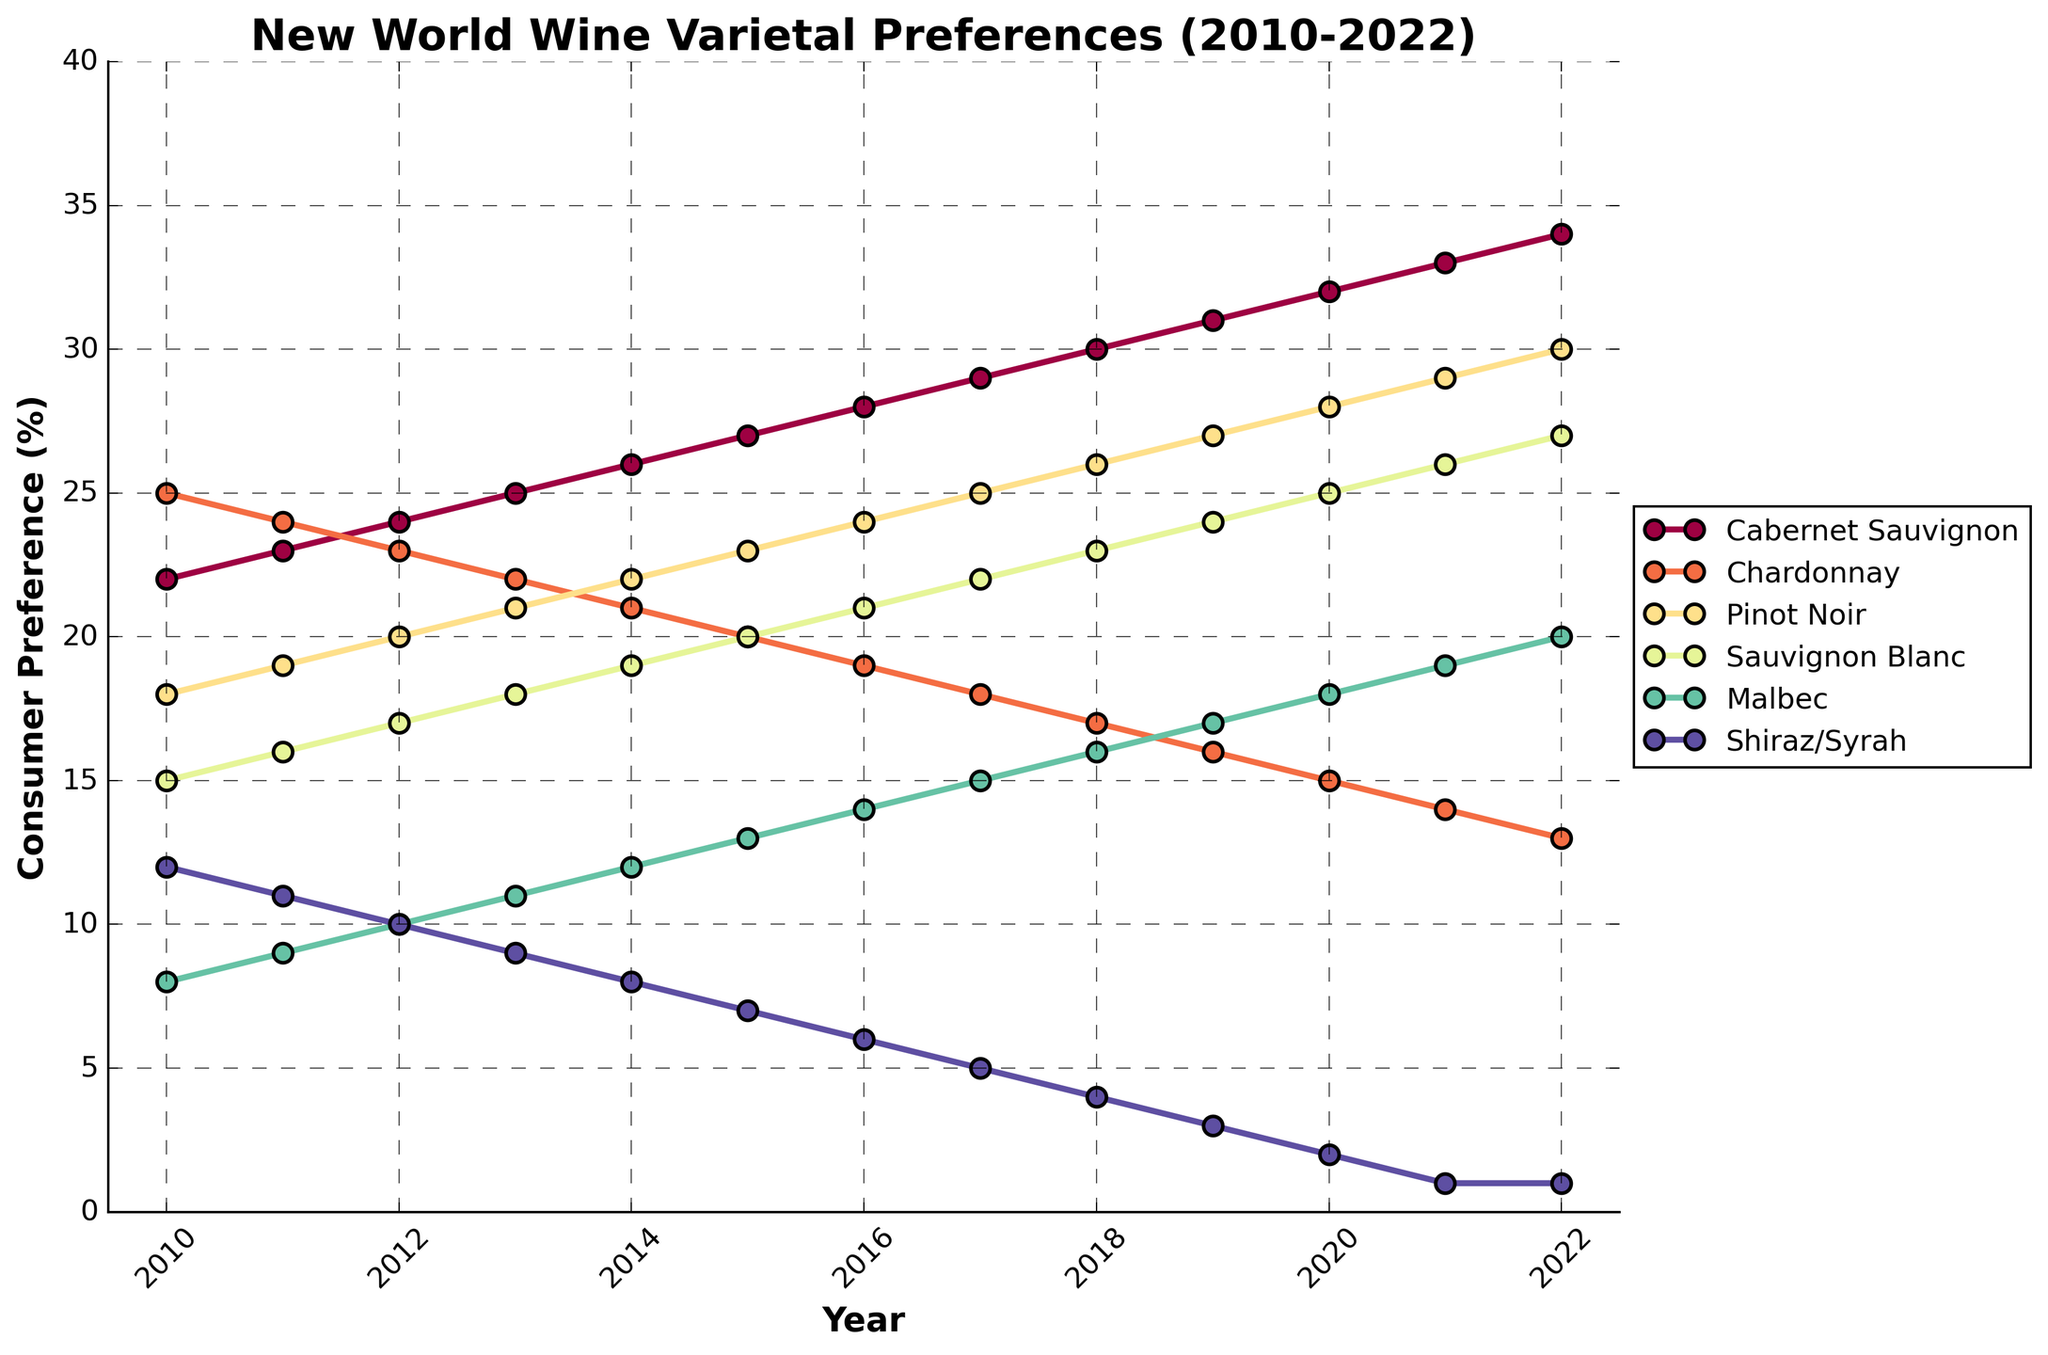Which varietal shows the most dramatic increase in consumer preference from 2010 to 2022? To find the varietal with the most dramatic increase from 2010 to 2022, check the starting and ending percentages for each varietal and calculate the difference. Cabernet Sauvignon goes from 22% to 34%, which is an increase of 12%.
Answer: Cabernet Sauvignon Comparing consumer preferences in 2010 and 2022, which varietal saw the most dramatic decrease? To determine the varietal with the most dramatic decrease, find the starting and ending preferences for each varietal and calculate the difference. Shiraz/Syrah had a preference of 12% in 2010 and decreased to 1% in 2022, a decrease of 11%.
Answer: Shiraz/Syrah Which two varietals have the smallest difference in consumer preference in the year 2020? Look at the percentages for all varietals in 2020, and then calculate the difference between each pair. The two varietals with the smallest difference are Chardonnay (15%) and Pinot Noir (28%), resulting in a difference of 1%.
Answer: Chardonnay and Shiraz/Syrah Which varietal had the highest consumer preference in 2015? Look at the consumer preference values for all varietals in 2015 and identify the highest percentage. Cabernet Sauvignon had the highest preference of 27%.
Answer: Cabernet Sauvignon What is the average consumer preference for Sauvignon Blanc across the years 2010 to 2015? Add up the yearly preferences for Sauvignon Blanc from 2010 to 2015: 15 + 16 + 17 + 18 + 19 + 20 = 105. Then divide by the number of years, which is 6, so 105 / 6 equals 17.5.
Answer: 17.5 In which year did Malbec overtake Shiraz/Syrah in consumer preference? Track the time series for both Malbec and Shiraz/Syrah and identify the year where Malbec's preference surpasses Shiraz/Syrah. This happened in 2011 when Malbec had 9% and Shiraz/Syrah had 11%.
Answer: 2011 How does the preference trend of Pinot Noir compare to that of Chardonnay from 2010 to 2022? Evaluate the overall trend lines for both Pinot Noir and Chardonnay. Pinot Noir shows a consistent upward trend, while Chardonnay shows a consistent downward trend throughout these years.
Answer: Pinot Noir increases while Chardonnay decreases Which year had the smallest total combined preference for all six varietals? Add the preferences for all six varietals for each year and find the year with the smallest total. For 2022, the total is 34 (Cabernet Sauvignon) + 13 (Chardonnay) + 30 (Pinot Noir) + 27 (Sauvignon Blanc) + 20 (Malbec) + 1 (Shiraz/Syrah) = 125.
Answer: 2022 What is the median preference of Cabernet Sauvignon from 2010 to 2022? List the preferences for Cabernet Sauvignon from 2010 to 2022: [22, 23, 24, 25, 26, 27, 28, 29, 30, 31, 32, 33, 34]. The median value, being the middle value when arranged in order, is 28.
Answer: 28 